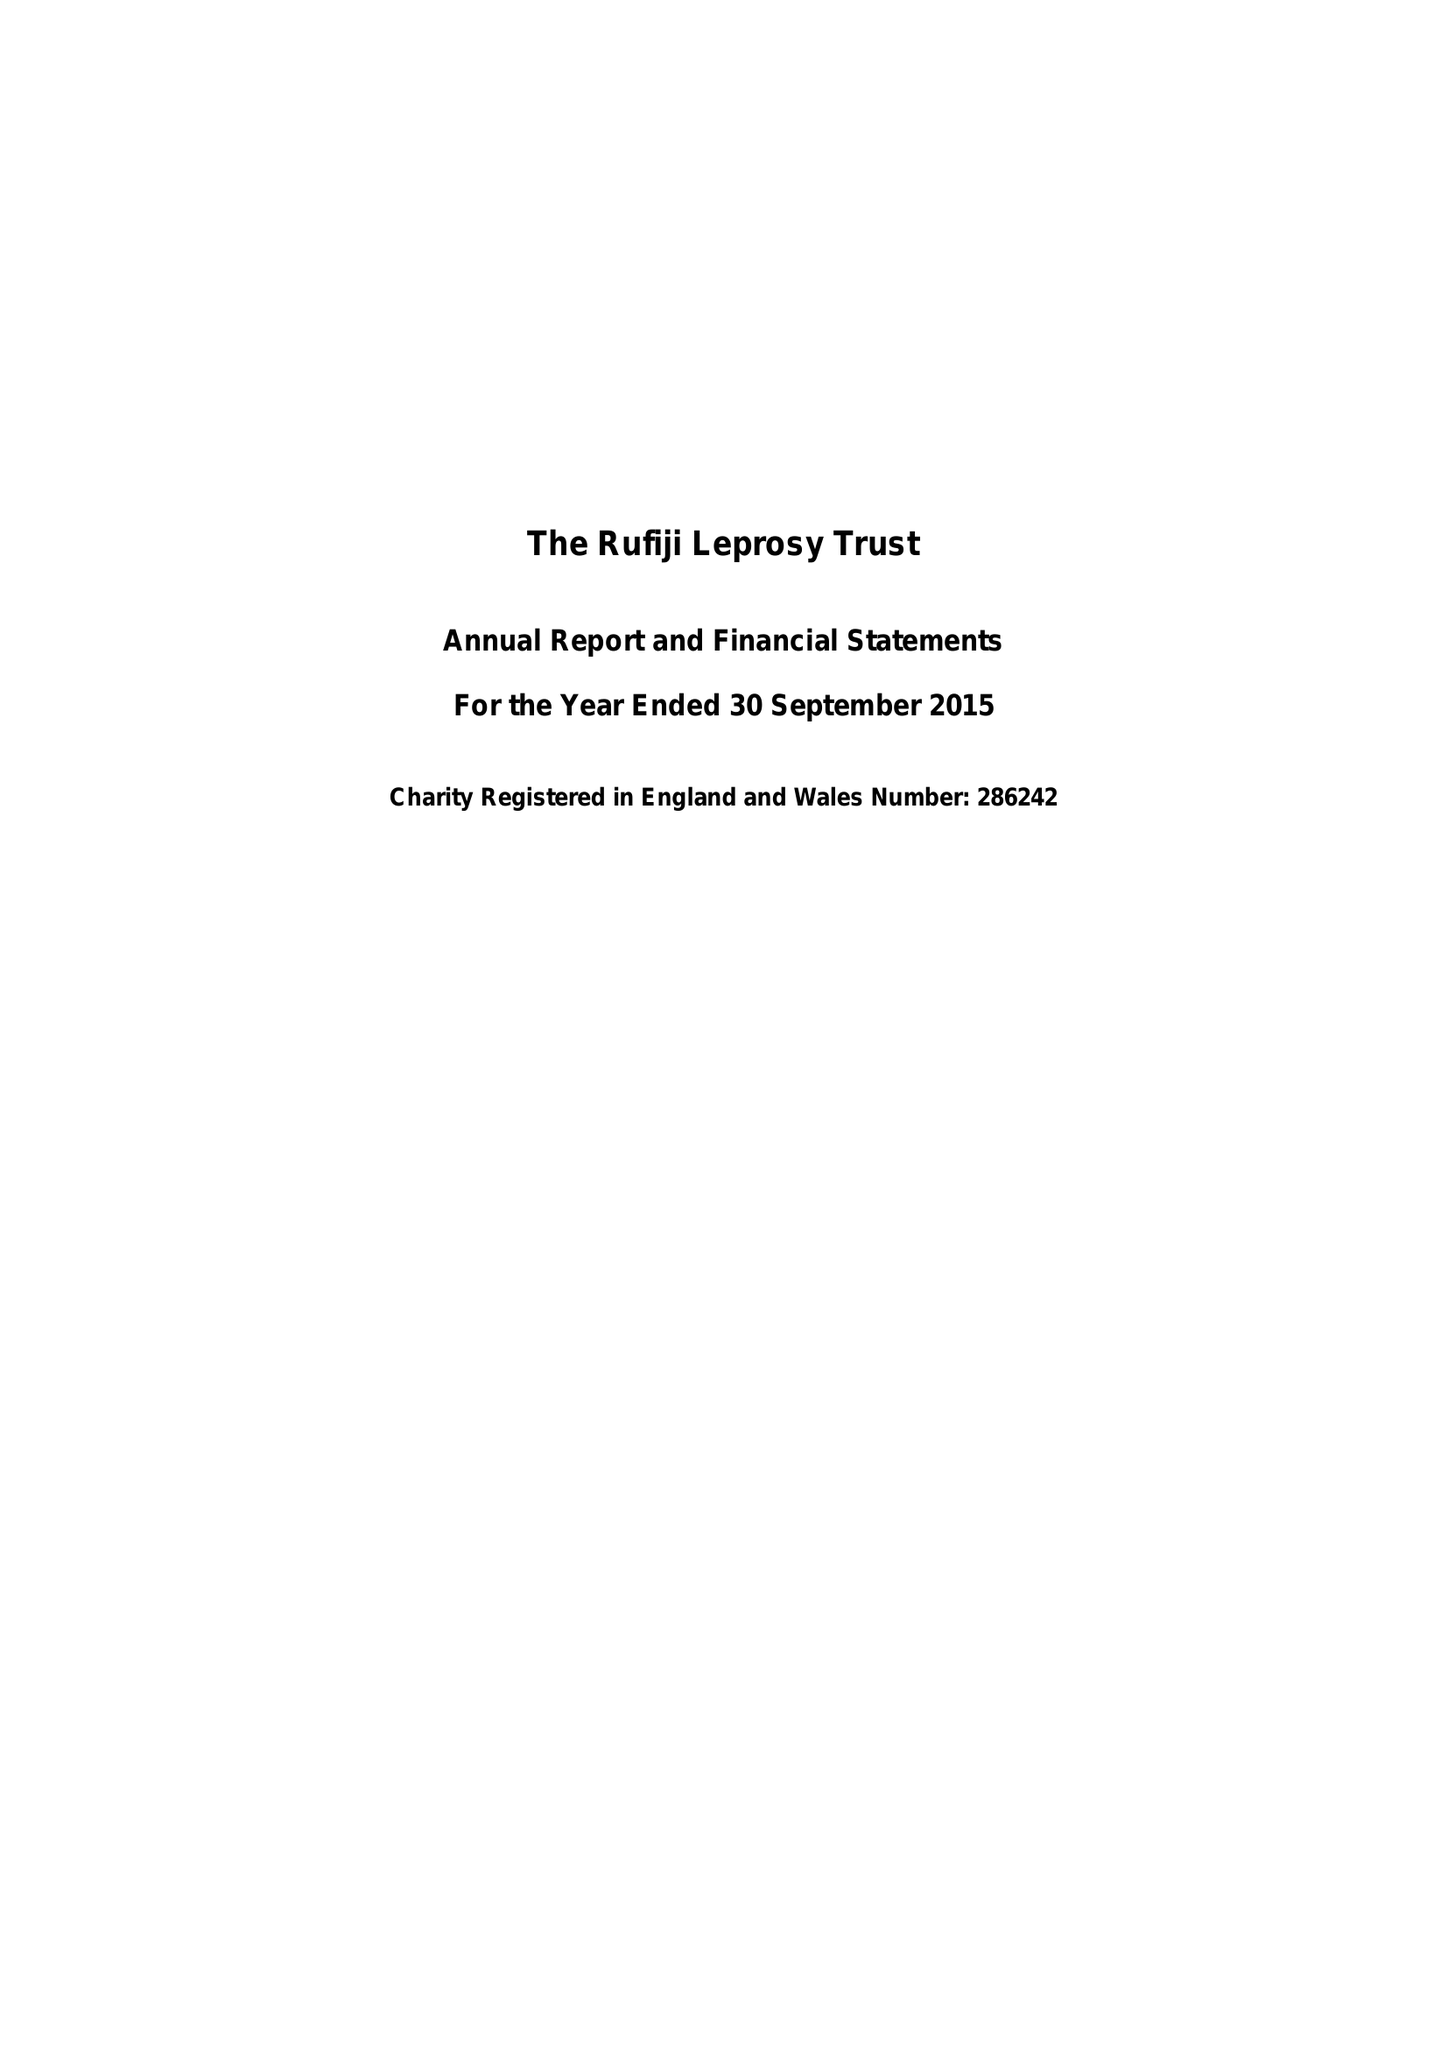What is the value for the address__postcode?
Answer the question using a single word or phrase. SE1 7JB 